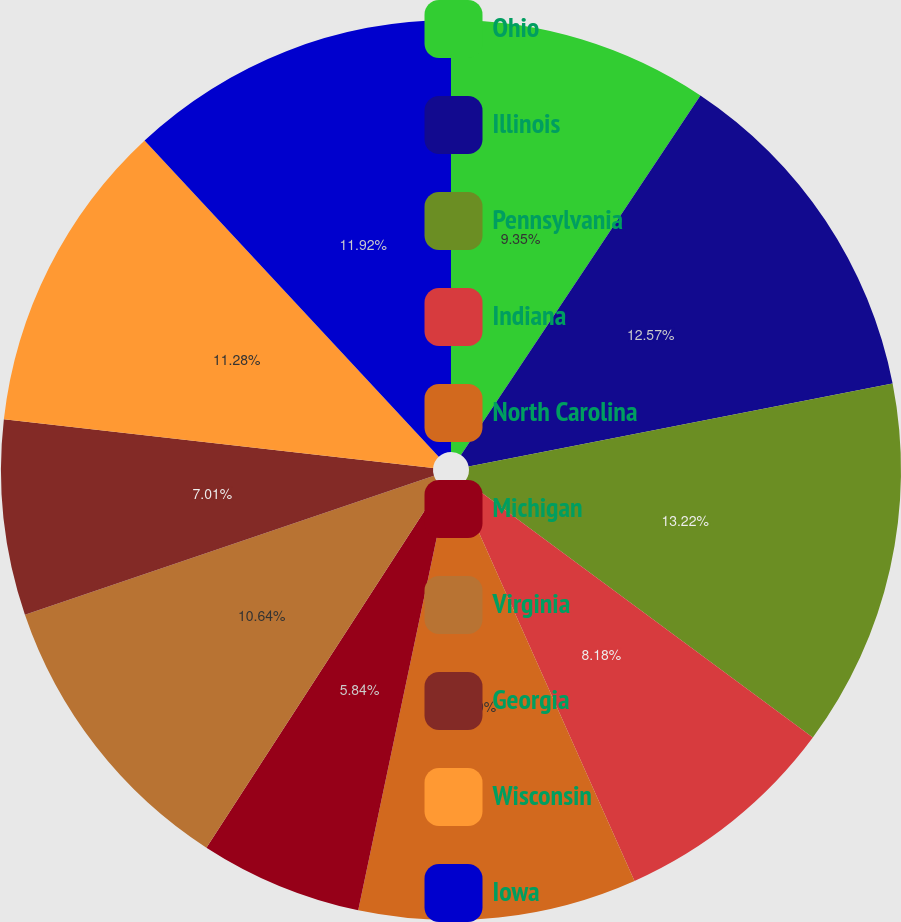<chart> <loc_0><loc_0><loc_500><loc_500><pie_chart><fcel>Ohio<fcel>Illinois<fcel>Pennsylvania<fcel>Indiana<fcel>North Carolina<fcel>Michigan<fcel>Virginia<fcel>Georgia<fcel>Wisconsin<fcel>Iowa<nl><fcel>9.35%<fcel>12.57%<fcel>13.21%<fcel>8.18%<fcel>9.99%<fcel>5.84%<fcel>10.64%<fcel>7.01%<fcel>11.28%<fcel>11.92%<nl></chart> 